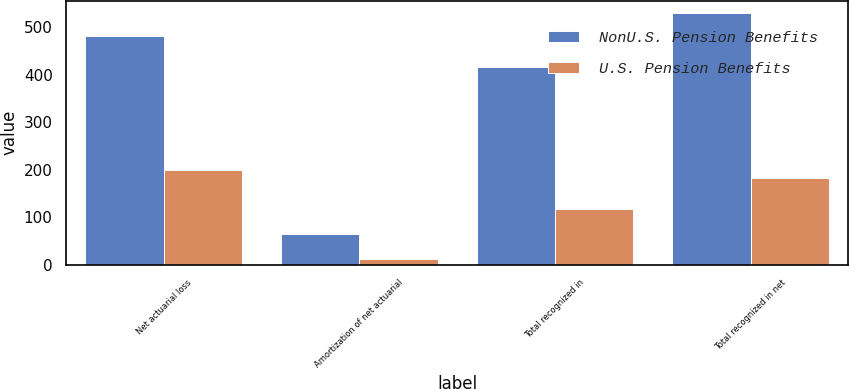Convert chart. <chart><loc_0><loc_0><loc_500><loc_500><stacked_bar_chart><ecel><fcel>Net actuarial loss<fcel>Amortization of net actuarial<fcel>Total recognized in<fcel>Total recognized in net<nl><fcel>NonU.S. Pension Benefits<fcel>481<fcel>65<fcel>416<fcel>530<nl><fcel>U.S. Pension Benefits<fcel>199<fcel>12<fcel>118<fcel>182<nl></chart> 